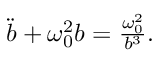<formula> <loc_0><loc_0><loc_500><loc_500>\begin{array} { r } { \ddot { b } + \omega _ { 0 } ^ { 2 } b = \frac { \omega _ { 0 } ^ { 2 } } { b ^ { 3 } } . } \end{array}</formula> 